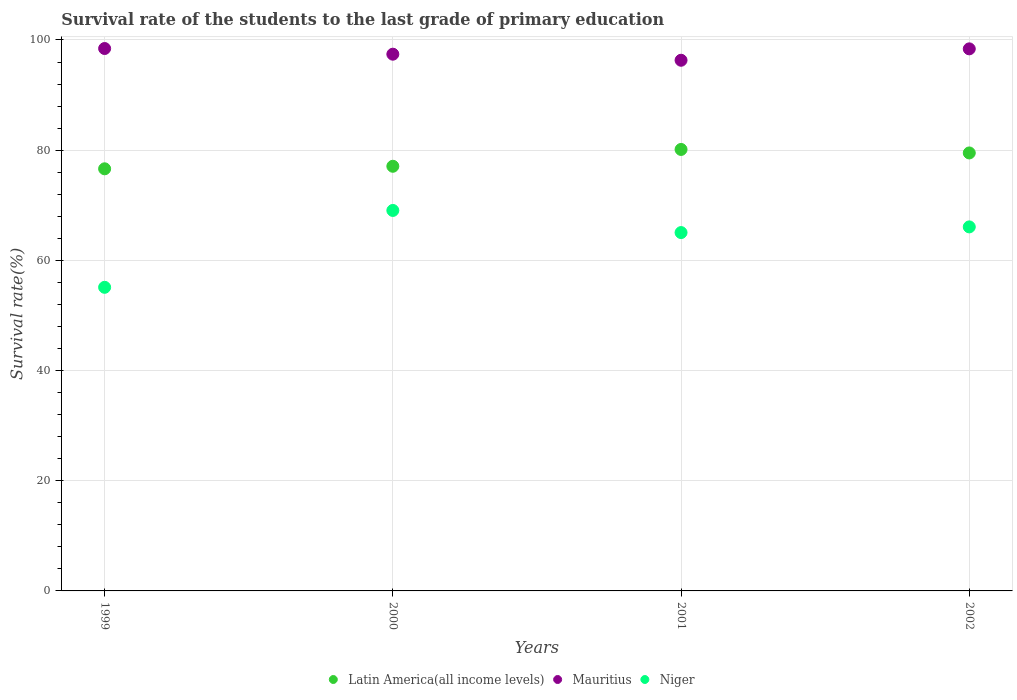Is the number of dotlines equal to the number of legend labels?
Make the answer very short. Yes. What is the survival rate of the students in Niger in 2002?
Provide a short and direct response. 66.07. Across all years, what is the maximum survival rate of the students in Niger?
Offer a very short reply. 69.06. Across all years, what is the minimum survival rate of the students in Latin America(all income levels)?
Give a very brief answer. 76.62. In which year was the survival rate of the students in Latin America(all income levels) maximum?
Ensure brevity in your answer.  2001. In which year was the survival rate of the students in Latin America(all income levels) minimum?
Make the answer very short. 1999. What is the total survival rate of the students in Niger in the graph?
Offer a terse response. 255.28. What is the difference between the survival rate of the students in Mauritius in 1999 and that in 2002?
Provide a short and direct response. 0.06. What is the difference between the survival rate of the students in Niger in 1999 and the survival rate of the students in Latin America(all income levels) in 2000?
Provide a succinct answer. -21.97. What is the average survival rate of the students in Mauritius per year?
Offer a terse response. 97.65. In the year 2001, what is the difference between the survival rate of the students in Latin America(all income levels) and survival rate of the students in Niger?
Keep it short and to the point. 15.09. What is the ratio of the survival rate of the students in Latin America(all income levels) in 2001 to that in 2002?
Provide a short and direct response. 1.01. Is the survival rate of the students in Mauritius in 2000 less than that in 2002?
Keep it short and to the point. Yes. What is the difference between the highest and the second highest survival rate of the students in Mauritius?
Your answer should be very brief. 0.06. What is the difference between the highest and the lowest survival rate of the students in Latin America(all income levels)?
Your answer should be compact. 3.51. Is it the case that in every year, the sum of the survival rate of the students in Latin America(all income levels) and survival rate of the students in Mauritius  is greater than the survival rate of the students in Niger?
Make the answer very short. Yes. Does the survival rate of the students in Niger monotonically increase over the years?
Keep it short and to the point. No. How many years are there in the graph?
Offer a terse response. 4. Does the graph contain any zero values?
Offer a terse response. No. Does the graph contain grids?
Your response must be concise. Yes. Where does the legend appear in the graph?
Offer a terse response. Bottom center. What is the title of the graph?
Your response must be concise. Survival rate of the students to the last grade of primary education. What is the label or title of the Y-axis?
Offer a terse response. Survival rate(%). What is the Survival rate(%) of Latin America(all income levels) in 1999?
Your response must be concise. 76.62. What is the Survival rate(%) of Mauritius in 1999?
Ensure brevity in your answer.  98.45. What is the Survival rate(%) in Niger in 1999?
Keep it short and to the point. 55.11. What is the Survival rate(%) of Latin America(all income levels) in 2000?
Give a very brief answer. 77.08. What is the Survival rate(%) of Mauritius in 2000?
Make the answer very short. 97.42. What is the Survival rate(%) in Niger in 2000?
Your answer should be compact. 69.06. What is the Survival rate(%) in Latin America(all income levels) in 2001?
Make the answer very short. 80.13. What is the Survival rate(%) in Mauritius in 2001?
Offer a terse response. 96.32. What is the Survival rate(%) of Niger in 2001?
Keep it short and to the point. 65.04. What is the Survival rate(%) of Latin America(all income levels) in 2002?
Offer a terse response. 79.5. What is the Survival rate(%) of Mauritius in 2002?
Offer a terse response. 98.39. What is the Survival rate(%) in Niger in 2002?
Make the answer very short. 66.07. Across all years, what is the maximum Survival rate(%) in Latin America(all income levels)?
Offer a terse response. 80.13. Across all years, what is the maximum Survival rate(%) in Mauritius?
Ensure brevity in your answer.  98.45. Across all years, what is the maximum Survival rate(%) in Niger?
Your answer should be compact. 69.06. Across all years, what is the minimum Survival rate(%) in Latin America(all income levels)?
Ensure brevity in your answer.  76.62. Across all years, what is the minimum Survival rate(%) in Mauritius?
Offer a very short reply. 96.32. Across all years, what is the minimum Survival rate(%) of Niger?
Your answer should be very brief. 55.11. What is the total Survival rate(%) in Latin America(all income levels) in the graph?
Ensure brevity in your answer.  313.32. What is the total Survival rate(%) of Mauritius in the graph?
Offer a terse response. 390.58. What is the total Survival rate(%) in Niger in the graph?
Provide a succinct answer. 255.28. What is the difference between the Survival rate(%) in Latin America(all income levels) in 1999 and that in 2000?
Your answer should be very brief. -0.46. What is the difference between the Survival rate(%) of Mauritius in 1999 and that in 2000?
Offer a terse response. 1.03. What is the difference between the Survival rate(%) in Niger in 1999 and that in 2000?
Keep it short and to the point. -13.95. What is the difference between the Survival rate(%) in Latin America(all income levels) in 1999 and that in 2001?
Offer a terse response. -3.51. What is the difference between the Survival rate(%) in Mauritius in 1999 and that in 2001?
Your response must be concise. 2.13. What is the difference between the Survival rate(%) in Niger in 1999 and that in 2001?
Make the answer very short. -9.94. What is the difference between the Survival rate(%) in Latin America(all income levels) in 1999 and that in 2002?
Offer a very short reply. -2.88. What is the difference between the Survival rate(%) of Mauritius in 1999 and that in 2002?
Give a very brief answer. 0.06. What is the difference between the Survival rate(%) of Niger in 1999 and that in 2002?
Keep it short and to the point. -10.97. What is the difference between the Survival rate(%) in Latin America(all income levels) in 2000 and that in 2001?
Your answer should be very brief. -3.05. What is the difference between the Survival rate(%) of Mauritius in 2000 and that in 2001?
Your response must be concise. 1.1. What is the difference between the Survival rate(%) in Niger in 2000 and that in 2001?
Offer a terse response. 4.02. What is the difference between the Survival rate(%) of Latin America(all income levels) in 2000 and that in 2002?
Your response must be concise. -2.42. What is the difference between the Survival rate(%) in Mauritius in 2000 and that in 2002?
Provide a succinct answer. -0.97. What is the difference between the Survival rate(%) of Niger in 2000 and that in 2002?
Your response must be concise. 2.99. What is the difference between the Survival rate(%) of Latin America(all income levels) in 2001 and that in 2002?
Ensure brevity in your answer.  0.63. What is the difference between the Survival rate(%) in Mauritius in 2001 and that in 2002?
Your answer should be very brief. -2.07. What is the difference between the Survival rate(%) of Niger in 2001 and that in 2002?
Your response must be concise. -1.03. What is the difference between the Survival rate(%) in Latin America(all income levels) in 1999 and the Survival rate(%) in Mauritius in 2000?
Your answer should be very brief. -20.8. What is the difference between the Survival rate(%) of Latin America(all income levels) in 1999 and the Survival rate(%) of Niger in 2000?
Offer a very short reply. 7.56. What is the difference between the Survival rate(%) of Mauritius in 1999 and the Survival rate(%) of Niger in 2000?
Offer a very short reply. 29.39. What is the difference between the Survival rate(%) in Latin America(all income levels) in 1999 and the Survival rate(%) in Mauritius in 2001?
Your response must be concise. -19.7. What is the difference between the Survival rate(%) in Latin America(all income levels) in 1999 and the Survival rate(%) in Niger in 2001?
Provide a succinct answer. 11.57. What is the difference between the Survival rate(%) in Mauritius in 1999 and the Survival rate(%) in Niger in 2001?
Offer a very short reply. 33.41. What is the difference between the Survival rate(%) of Latin America(all income levels) in 1999 and the Survival rate(%) of Mauritius in 2002?
Offer a terse response. -21.77. What is the difference between the Survival rate(%) in Latin America(all income levels) in 1999 and the Survival rate(%) in Niger in 2002?
Give a very brief answer. 10.54. What is the difference between the Survival rate(%) in Mauritius in 1999 and the Survival rate(%) in Niger in 2002?
Offer a terse response. 32.38. What is the difference between the Survival rate(%) in Latin America(all income levels) in 2000 and the Survival rate(%) in Mauritius in 2001?
Offer a very short reply. -19.24. What is the difference between the Survival rate(%) of Latin America(all income levels) in 2000 and the Survival rate(%) of Niger in 2001?
Ensure brevity in your answer.  12.03. What is the difference between the Survival rate(%) of Mauritius in 2000 and the Survival rate(%) of Niger in 2001?
Your answer should be compact. 32.38. What is the difference between the Survival rate(%) of Latin America(all income levels) in 2000 and the Survival rate(%) of Mauritius in 2002?
Make the answer very short. -21.31. What is the difference between the Survival rate(%) of Latin America(all income levels) in 2000 and the Survival rate(%) of Niger in 2002?
Provide a succinct answer. 11. What is the difference between the Survival rate(%) of Mauritius in 2000 and the Survival rate(%) of Niger in 2002?
Keep it short and to the point. 31.35. What is the difference between the Survival rate(%) in Latin America(all income levels) in 2001 and the Survival rate(%) in Mauritius in 2002?
Offer a terse response. -18.26. What is the difference between the Survival rate(%) of Latin America(all income levels) in 2001 and the Survival rate(%) of Niger in 2002?
Give a very brief answer. 14.06. What is the difference between the Survival rate(%) of Mauritius in 2001 and the Survival rate(%) of Niger in 2002?
Your response must be concise. 30.25. What is the average Survival rate(%) of Latin America(all income levels) per year?
Ensure brevity in your answer.  78.33. What is the average Survival rate(%) of Mauritius per year?
Offer a very short reply. 97.65. What is the average Survival rate(%) in Niger per year?
Make the answer very short. 63.82. In the year 1999, what is the difference between the Survival rate(%) in Latin America(all income levels) and Survival rate(%) in Mauritius?
Your response must be concise. -21.83. In the year 1999, what is the difference between the Survival rate(%) of Latin America(all income levels) and Survival rate(%) of Niger?
Make the answer very short. 21.51. In the year 1999, what is the difference between the Survival rate(%) of Mauritius and Survival rate(%) of Niger?
Offer a very short reply. 43.34. In the year 2000, what is the difference between the Survival rate(%) in Latin America(all income levels) and Survival rate(%) in Mauritius?
Provide a succinct answer. -20.34. In the year 2000, what is the difference between the Survival rate(%) of Latin America(all income levels) and Survival rate(%) of Niger?
Make the answer very short. 8.02. In the year 2000, what is the difference between the Survival rate(%) of Mauritius and Survival rate(%) of Niger?
Make the answer very short. 28.36. In the year 2001, what is the difference between the Survival rate(%) of Latin America(all income levels) and Survival rate(%) of Mauritius?
Provide a short and direct response. -16.19. In the year 2001, what is the difference between the Survival rate(%) in Latin America(all income levels) and Survival rate(%) in Niger?
Make the answer very short. 15.09. In the year 2001, what is the difference between the Survival rate(%) in Mauritius and Survival rate(%) in Niger?
Your response must be concise. 31.28. In the year 2002, what is the difference between the Survival rate(%) in Latin America(all income levels) and Survival rate(%) in Mauritius?
Give a very brief answer. -18.89. In the year 2002, what is the difference between the Survival rate(%) in Latin America(all income levels) and Survival rate(%) in Niger?
Provide a short and direct response. 13.42. In the year 2002, what is the difference between the Survival rate(%) in Mauritius and Survival rate(%) in Niger?
Offer a terse response. 32.32. What is the ratio of the Survival rate(%) of Mauritius in 1999 to that in 2000?
Offer a very short reply. 1.01. What is the ratio of the Survival rate(%) of Niger in 1999 to that in 2000?
Provide a short and direct response. 0.8. What is the ratio of the Survival rate(%) in Latin America(all income levels) in 1999 to that in 2001?
Keep it short and to the point. 0.96. What is the ratio of the Survival rate(%) of Mauritius in 1999 to that in 2001?
Your answer should be compact. 1.02. What is the ratio of the Survival rate(%) in Niger in 1999 to that in 2001?
Your answer should be compact. 0.85. What is the ratio of the Survival rate(%) of Latin America(all income levels) in 1999 to that in 2002?
Your answer should be compact. 0.96. What is the ratio of the Survival rate(%) in Mauritius in 1999 to that in 2002?
Keep it short and to the point. 1. What is the ratio of the Survival rate(%) of Niger in 1999 to that in 2002?
Give a very brief answer. 0.83. What is the ratio of the Survival rate(%) in Latin America(all income levels) in 2000 to that in 2001?
Keep it short and to the point. 0.96. What is the ratio of the Survival rate(%) of Mauritius in 2000 to that in 2001?
Your answer should be compact. 1.01. What is the ratio of the Survival rate(%) in Niger in 2000 to that in 2001?
Your answer should be compact. 1.06. What is the ratio of the Survival rate(%) in Latin America(all income levels) in 2000 to that in 2002?
Keep it short and to the point. 0.97. What is the ratio of the Survival rate(%) in Mauritius in 2000 to that in 2002?
Your answer should be very brief. 0.99. What is the ratio of the Survival rate(%) of Niger in 2000 to that in 2002?
Offer a very short reply. 1.05. What is the ratio of the Survival rate(%) in Mauritius in 2001 to that in 2002?
Your response must be concise. 0.98. What is the ratio of the Survival rate(%) of Niger in 2001 to that in 2002?
Keep it short and to the point. 0.98. What is the difference between the highest and the second highest Survival rate(%) of Latin America(all income levels)?
Make the answer very short. 0.63. What is the difference between the highest and the second highest Survival rate(%) in Mauritius?
Offer a very short reply. 0.06. What is the difference between the highest and the second highest Survival rate(%) in Niger?
Your answer should be very brief. 2.99. What is the difference between the highest and the lowest Survival rate(%) of Latin America(all income levels)?
Keep it short and to the point. 3.51. What is the difference between the highest and the lowest Survival rate(%) in Mauritius?
Your answer should be compact. 2.13. What is the difference between the highest and the lowest Survival rate(%) in Niger?
Your answer should be very brief. 13.95. 